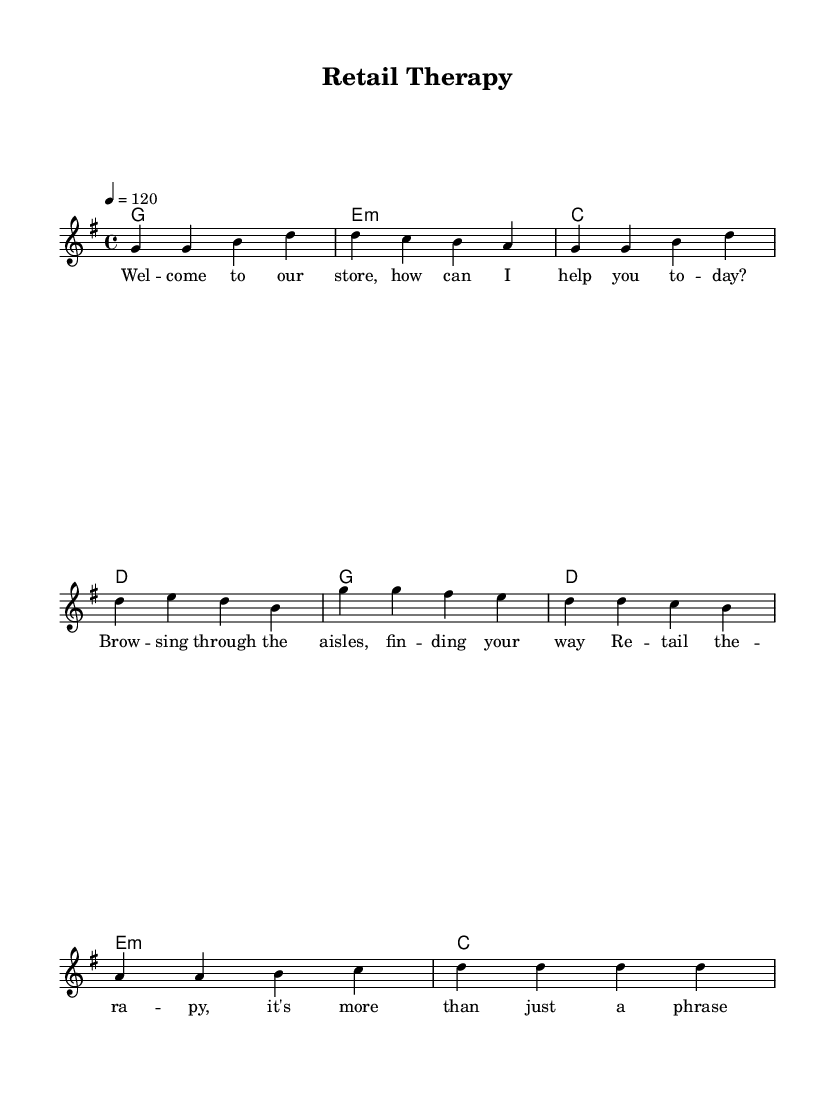What is the key signature of this music? The key signature is G major, which has one sharp (F#).
Answer: G major What is the time signature of this music? The time signature is 4/4, indicating four beats per measure.
Answer: 4/4 What is the tempo of this piece? The tempo marking indicates a speed of 120 beats per minute.
Answer: 120 How many measures are in the verse? The verse consists of four measures, as indicated by the grouping of notes.
Answer: Four measures What is the first lyric line of the chorus? The first lyric line of the chorus is "Re -- tail the -- ra -- py," which is noted above the corresponding melody.
Answer: "Re -- tail the -- ra -- py." How many chords are used in the verse section? The verse features four distinct chords, each corresponding to a measure.
Answer: Four chords What is the musical theme of the lyrics? The lyrics revolve around customer service experiences in a retail environment, indicating a welcoming and helpful attitude.
Answer: Customer service experiences 